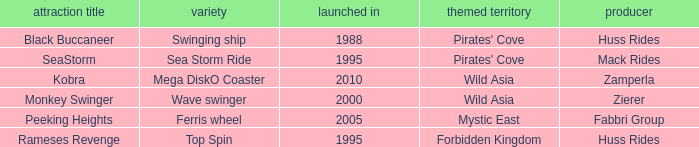What type ride is Wild Asia that opened in 2000? Wave swinger. 